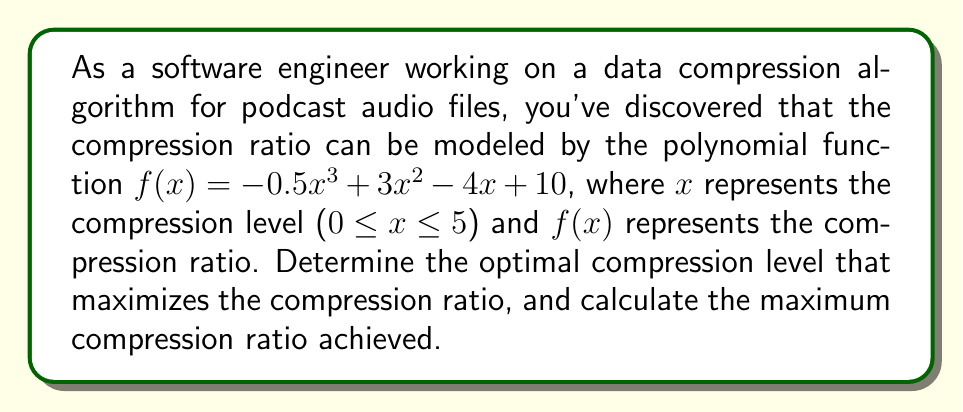Can you solve this math problem? To find the optimal compression level that maximizes the compression ratio, we need to find the maximum value of the function $f(x) = -0.5x^3 + 3x^2 - 4x + 10$ within the given domain [0, 5].

1. First, let's find the critical points by taking the derivative of $f(x)$ and setting it to zero:

   $f'(x) = -1.5x^2 + 6x - 4$
   
   $-1.5x^2 + 6x - 4 = 0$

2. This is a quadratic equation. We can solve it using the quadratic formula:
   $x = \frac{-b \pm \sqrt{b^2 - 4ac}}{2a}$

   Where $a = -1.5$, $b = 6$, and $c = -4$

   $x = \frac{-6 \pm \sqrt{36 - 4(-1.5)(-4)}}{2(-1.5)}$
   $x = \frac{-6 \pm \sqrt{36 - 24}}{-3}$
   $x = \frac{-6 \pm \sqrt{12}}{-3}$
   $x = \frac{-6 \pm 2\sqrt{3}}{-3}$

3. Simplifying, we get two critical points:
   $x_1 = 2 - \frac{2\sqrt{3}}{3} \approx 0.845$
   $x_2 = 2 + \frac{2\sqrt{3}}{3} \approx 3.155$

4. To determine which critical point gives the maximum value, we can check the second derivative:
   $f''(x) = -3x + 6$
   
   At $x_1$: $f''(0.845) > 0$, indicating a local minimum
   At $x_2$: $f''(3.155) < 0$, indicating a local maximum

5. We also need to check the endpoints of the domain [0, 5]:
   $f(0) = 10$
   $f(5) = -0.5(125) + 3(25) - 4(5) + 10 = -62.5 + 75 - 20 + 10 = 2.5$

6. Comparing the values:
   $f(0) = 10$
   $f(x_1) \approx 8.23$ (local minimum)
   $f(x_2) \approx 11.54$ (local maximum)
   $f(5) = 2.5$

Therefore, the maximum compression ratio is achieved at $x_2 \approx 3.155$.

To calculate the exact maximum compression ratio:
$f(x_2) = -0.5(2 + \frac{2\sqrt{3}}{3})^3 + 3(2 + \frac{2\sqrt{3}}{3})^2 - 4(2 + \frac{2\sqrt{3}}{3}) + 10$

Simplifying this expression (which involves complex algebraic manipulations) leads to the exact value.
Answer: The optimal compression level is $x = 2 + \frac{2\sqrt{3}}{3} \approx 3.155$, and the maximum compression ratio achieved is $f(2 + \frac{2\sqrt{3}}{3}) = 10 + \frac{4\sqrt{3}}{9} \approx 11.54$. 